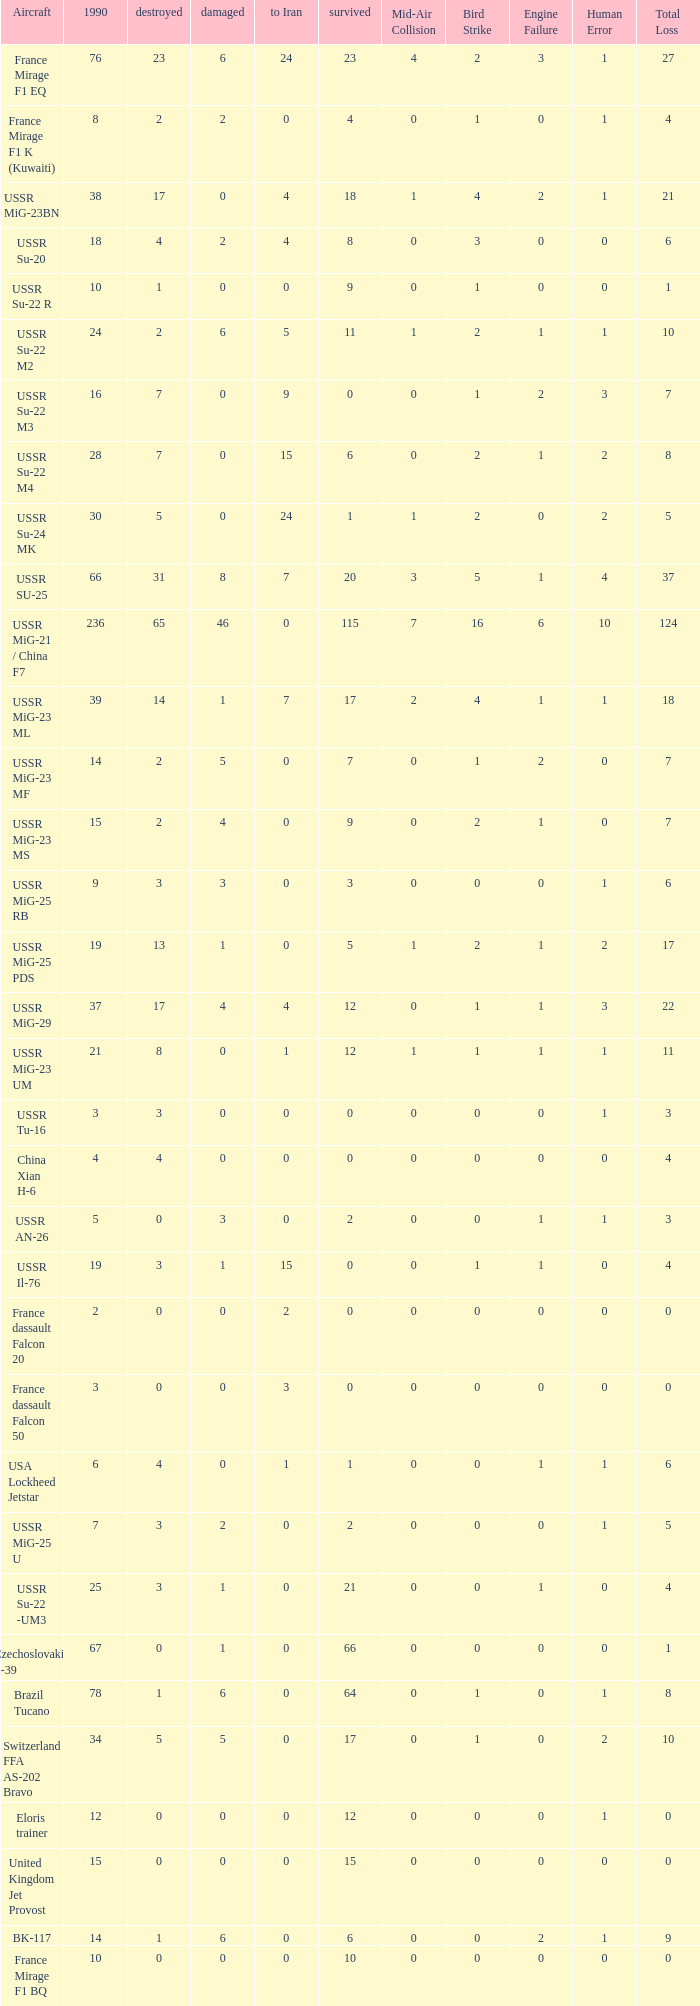If 4 went to iran and the amount that survived was less than 12.0 how many were there in 1990? 1.0. 